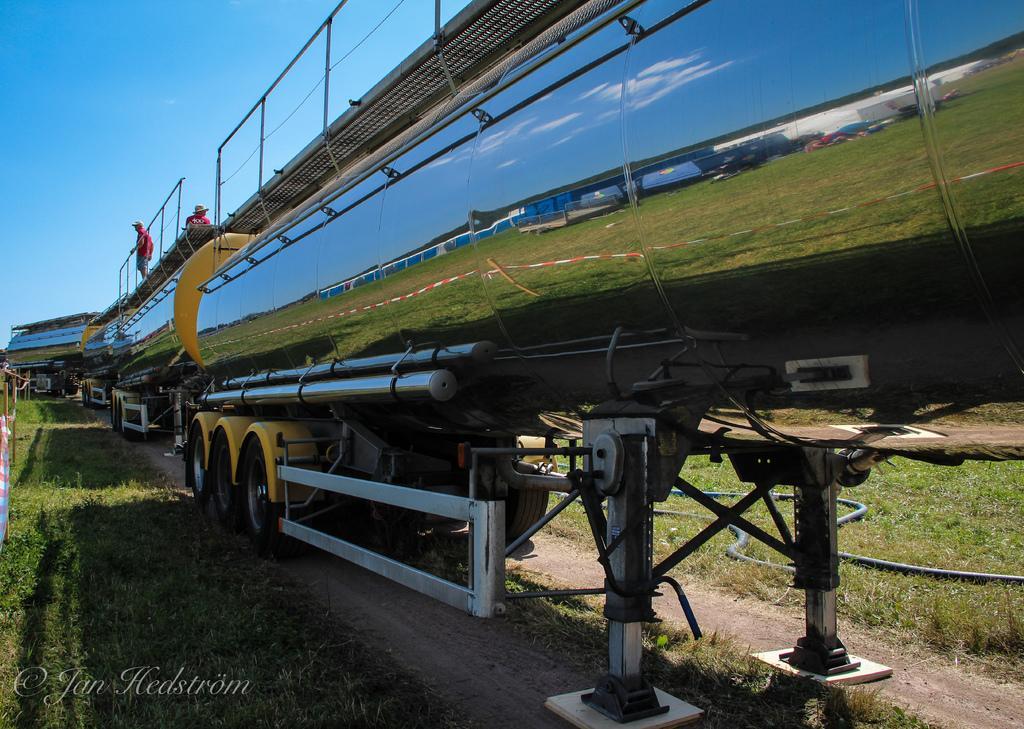Could you give a brief overview of what you see in this image? In this image we can see a motor vehicle, persons, ground and sky. 